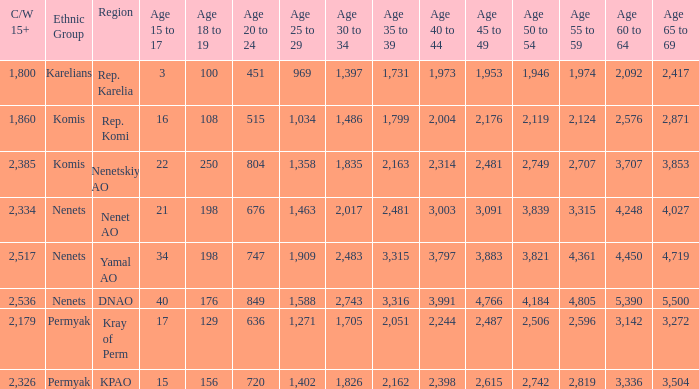What is the number of 40 to 44 when the 50 to 54 is less than 4,184, and the 15 to 17 is less than 3? 0.0. 